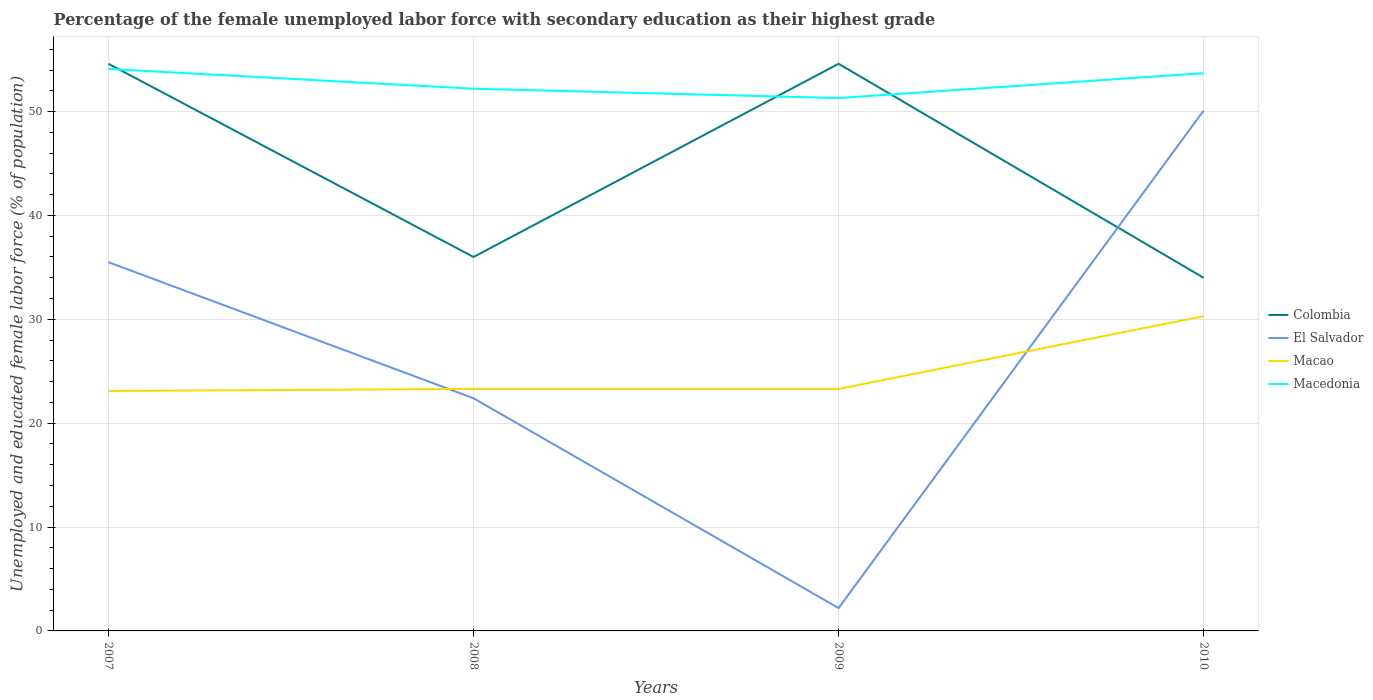Does the line corresponding to Macedonia intersect with the line corresponding to El Salvador?
Offer a terse response. No. Across all years, what is the maximum percentage of the unemployed female labor force with secondary education in Macedonia?
Ensure brevity in your answer.  51.3. In which year was the percentage of the unemployed female labor force with secondary education in Macedonia maximum?
Give a very brief answer. 2009. What is the total percentage of the unemployed female labor force with secondary education in El Salvador in the graph?
Your answer should be very brief. 13.1. What is the difference between the highest and the second highest percentage of the unemployed female labor force with secondary education in Macedonia?
Give a very brief answer. 2.8. Is the percentage of the unemployed female labor force with secondary education in Macao strictly greater than the percentage of the unemployed female labor force with secondary education in El Salvador over the years?
Provide a succinct answer. No. How many lines are there?
Your response must be concise. 4. Are the values on the major ticks of Y-axis written in scientific E-notation?
Offer a terse response. No. Does the graph contain any zero values?
Your response must be concise. No. How are the legend labels stacked?
Your answer should be very brief. Vertical. What is the title of the graph?
Make the answer very short. Percentage of the female unemployed labor force with secondary education as their highest grade. Does "High income" appear as one of the legend labels in the graph?
Provide a short and direct response. No. What is the label or title of the X-axis?
Make the answer very short. Years. What is the label or title of the Y-axis?
Give a very brief answer. Unemployed and educated female labor force (% of population). What is the Unemployed and educated female labor force (% of population) of Colombia in 2007?
Provide a short and direct response. 54.6. What is the Unemployed and educated female labor force (% of population) in El Salvador in 2007?
Ensure brevity in your answer.  35.5. What is the Unemployed and educated female labor force (% of population) in Macao in 2007?
Offer a terse response. 23.1. What is the Unemployed and educated female labor force (% of population) in Macedonia in 2007?
Ensure brevity in your answer.  54.1. What is the Unemployed and educated female labor force (% of population) in El Salvador in 2008?
Your answer should be compact. 22.4. What is the Unemployed and educated female labor force (% of population) of Macao in 2008?
Make the answer very short. 23.3. What is the Unemployed and educated female labor force (% of population) of Macedonia in 2008?
Offer a terse response. 52.2. What is the Unemployed and educated female labor force (% of population) in Colombia in 2009?
Keep it short and to the point. 54.6. What is the Unemployed and educated female labor force (% of population) of El Salvador in 2009?
Provide a short and direct response. 2.2. What is the Unemployed and educated female labor force (% of population) in Macao in 2009?
Your response must be concise. 23.3. What is the Unemployed and educated female labor force (% of population) in Macedonia in 2009?
Provide a succinct answer. 51.3. What is the Unemployed and educated female labor force (% of population) in Colombia in 2010?
Your response must be concise. 34. What is the Unemployed and educated female labor force (% of population) of El Salvador in 2010?
Ensure brevity in your answer.  50.1. What is the Unemployed and educated female labor force (% of population) in Macao in 2010?
Provide a short and direct response. 30.3. What is the Unemployed and educated female labor force (% of population) in Macedonia in 2010?
Your answer should be very brief. 53.7. Across all years, what is the maximum Unemployed and educated female labor force (% of population) of Colombia?
Your response must be concise. 54.6. Across all years, what is the maximum Unemployed and educated female labor force (% of population) of El Salvador?
Offer a very short reply. 50.1. Across all years, what is the maximum Unemployed and educated female labor force (% of population) in Macao?
Give a very brief answer. 30.3. Across all years, what is the maximum Unemployed and educated female labor force (% of population) of Macedonia?
Your answer should be compact. 54.1. Across all years, what is the minimum Unemployed and educated female labor force (% of population) of Colombia?
Give a very brief answer. 34. Across all years, what is the minimum Unemployed and educated female labor force (% of population) of El Salvador?
Keep it short and to the point. 2.2. Across all years, what is the minimum Unemployed and educated female labor force (% of population) in Macao?
Give a very brief answer. 23.1. Across all years, what is the minimum Unemployed and educated female labor force (% of population) of Macedonia?
Provide a succinct answer. 51.3. What is the total Unemployed and educated female labor force (% of population) of Colombia in the graph?
Provide a succinct answer. 179.2. What is the total Unemployed and educated female labor force (% of population) in El Salvador in the graph?
Give a very brief answer. 110.2. What is the total Unemployed and educated female labor force (% of population) in Macao in the graph?
Provide a short and direct response. 100. What is the total Unemployed and educated female labor force (% of population) in Macedonia in the graph?
Keep it short and to the point. 211.3. What is the difference between the Unemployed and educated female labor force (% of population) in Colombia in 2007 and that in 2008?
Offer a terse response. 18.6. What is the difference between the Unemployed and educated female labor force (% of population) of El Salvador in 2007 and that in 2008?
Provide a short and direct response. 13.1. What is the difference between the Unemployed and educated female labor force (% of population) in Macao in 2007 and that in 2008?
Offer a very short reply. -0.2. What is the difference between the Unemployed and educated female labor force (% of population) in El Salvador in 2007 and that in 2009?
Make the answer very short. 33.3. What is the difference between the Unemployed and educated female labor force (% of population) in Macao in 2007 and that in 2009?
Provide a succinct answer. -0.2. What is the difference between the Unemployed and educated female labor force (% of population) of Macedonia in 2007 and that in 2009?
Ensure brevity in your answer.  2.8. What is the difference between the Unemployed and educated female labor force (% of population) in Colombia in 2007 and that in 2010?
Keep it short and to the point. 20.6. What is the difference between the Unemployed and educated female labor force (% of population) of El Salvador in 2007 and that in 2010?
Provide a short and direct response. -14.6. What is the difference between the Unemployed and educated female labor force (% of population) in Macedonia in 2007 and that in 2010?
Offer a terse response. 0.4. What is the difference between the Unemployed and educated female labor force (% of population) in Colombia in 2008 and that in 2009?
Offer a terse response. -18.6. What is the difference between the Unemployed and educated female labor force (% of population) of El Salvador in 2008 and that in 2009?
Provide a succinct answer. 20.2. What is the difference between the Unemployed and educated female labor force (% of population) of Macedonia in 2008 and that in 2009?
Ensure brevity in your answer.  0.9. What is the difference between the Unemployed and educated female labor force (% of population) of El Salvador in 2008 and that in 2010?
Ensure brevity in your answer.  -27.7. What is the difference between the Unemployed and educated female labor force (% of population) in Macao in 2008 and that in 2010?
Provide a short and direct response. -7. What is the difference between the Unemployed and educated female labor force (% of population) in Macedonia in 2008 and that in 2010?
Ensure brevity in your answer.  -1.5. What is the difference between the Unemployed and educated female labor force (% of population) in Colombia in 2009 and that in 2010?
Provide a succinct answer. 20.6. What is the difference between the Unemployed and educated female labor force (% of population) in El Salvador in 2009 and that in 2010?
Offer a very short reply. -47.9. What is the difference between the Unemployed and educated female labor force (% of population) in Macao in 2009 and that in 2010?
Offer a terse response. -7. What is the difference between the Unemployed and educated female labor force (% of population) of Colombia in 2007 and the Unemployed and educated female labor force (% of population) of El Salvador in 2008?
Provide a short and direct response. 32.2. What is the difference between the Unemployed and educated female labor force (% of population) of Colombia in 2007 and the Unemployed and educated female labor force (% of population) of Macao in 2008?
Provide a short and direct response. 31.3. What is the difference between the Unemployed and educated female labor force (% of population) in Colombia in 2007 and the Unemployed and educated female labor force (% of population) in Macedonia in 2008?
Give a very brief answer. 2.4. What is the difference between the Unemployed and educated female labor force (% of population) in El Salvador in 2007 and the Unemployed and educated female labor force (% of population) in Macedonia in 2008?
Make the answer very short. -16.7. What is the difference between the Unemployed and educated female labor force (% of population) of Macao in 2007 and the Unemployed and educated female labor force (% of population) of Macedonia in 2008?
Your response must be concise. -29.1. What is the difference between the Unemployed and educated female labor force (% of population) in Colombia in 2007 and the Unemployed and educated female labor force (% of population) in El Salvador in 2009?
Give a very brief answer. 52.4. What is the difference between the Unemployed and educated female labor force (% of population) in Colombia in 2007 and the Unemployed and educated female labor force (% of population) in Macao in 2009?
Offer a terse response. 31.3. What is the difference between the Unemployed and educated female labor force (% of population) in El Salvador in 2007 and the Unemployed and educated female labor force (% of population) in Macao in 2009?
Offer a very short reply. 12.2. What is the difference between the Unemployed and educated female labor force (% of population) of El Salvador in 2007 and the Unemployed and educated female labor force (% of population) of Macedonia in 2009?
Provide a succinct answer. -15.8. What is the difference between the Unemployed and educated female labor force (% of population) in Macao in 2007 and the Unemployed and educated female labor force (% of population) in Macedonia in 2009?
Provide a succinct answer. -28.2. What is the difference between the Unemployed and educated female labor force (% of population) of Colombia in 2007 and the Unemployed and educated female labor force (% of population) of El Salvador in 2010?
Offer a terse response. 4.5. What is the difference between the Unemployed and educated female labor force (% of population) in Colombia in 2007 and the Unemployed and educated female labor force (% of population) in Macao in 2010?
Offer a terse response. 24.3. What is the difference between the Unemployed and educated female labor force (% of population) in El Salvador in 2007 and the Unemployed and educated female labor force (% of population) in Macedonia in 2010?
Your answer should be compact. -18.2. What is the difference between the Unemployed and educated female labor force (% of population) in Macao in 2007 and the Unemployed and educated female labor force (% of population) in Macedonia in 2010?
Provide a short and direct response. -30.6. What is the difference between the Unemployed and educated female labor force (% of population) in Colombia in 2008 and the Unemployed and educated female labor force (% of population) in El Salvador in 2009?
Offer a terse response. 33.8. What is the difference between the Unemployed and educated female labor force (% of population) in Colombia in 2008 and the Unemployed and educated female labor force (% of population) in Macedonia in 2009?
Your response must be concise. -15.3. What is the difference between the Unemployed and educated female labor force (% of population) of El Salvador in 2008 and the Unemployed and educated female labor force (% of population) of Macao in 2009?
Give a very brief answer. -0.9. What is the difference between the Unemployed and educated female labor force (% of population) in El Salvador in 2008 and the Unemployed and educated female labor force (% of population) in Macedonia in 2009?
Keep it short and to the point. -28.9. What is the difference between the Unemployed and educated female labor force (% of population) of Colombia in 2008 and the Unemployed and educated female labor force (% of population) of El Salvador in 2010?
Your answer should be compact. -14.1. What is the difference between the Unemployed and educated female labor force (% of population) in Colombia in 2008 and the Unemployed and educated female labor force (% of population) in Macedonia in 2010?
Your answer should be compact. -17.7. What is the difference between the Unemployed and educated female labor force (% of population) in El Salvador in 2008 and the Unemployed and educated female labor force (% of population) in Macedonia in 2010?
Offer a terse response. -31.3. What is the difference between the Unemployed and educated female labor force (% of population) of Macao in 2008 and the Unemployed and educated female labor force (% of population) of Macedonia in 2010?
Give a very brief answer. -30.4. What is the difference between the Unemployed and educated female labor force (% of population) of Colombia in 2009 and the Unemployed and educated female labor force (% of population) of El Salvador in 2010?
Make the answer very short. 4.5. What is the difference between the Unemployed and educated female labor force (% of population) in Colombia in 2009 and the Unemployed and educated female labor force (% of population) in Macao in 2010?
Offer a terse response. 24.3. What is the difference between the Unemployed and educated female labor force (% of population) in El Salvador in 2009 and the Unemployed and educated female labor force (% of population) in Macao in 2010?
Offer a very short reply. -28.1. What is the difference between the Unemployed and educated female labor force (% of population) of El Salvador in 2009 and the Unemployed and educated female labor force (% of population) of Macedonia in 2010?
Make the answer very short. -51.5. What is the difference between the Unemployed and educated female labor force (% of population) in Macao in 2009 and the Unemployed and educated female labor force (% of population) in Macedonia in 2010?
Offer a terse response. -30.4. What is the average Unemployed and educated female labor force (% of population) in Colombia per year?
Your answer should be compact. 44.8. What is the average Unemployed and educated female labor force (% of population) in El Salvador per year?
Your answer should be compact. 27.55. What is the average Unemployed and educated female labor force (% of population) of Macedonia per year?
Make the answer very short. 52.83. In the year 2007, what is the difference between the Unemployed and educated female labor force (% of population) in Colombia and Unemployed and educated female labor force (% of population) in Macao?
Offer a very short reply. 31.5. In the year 2007, what is the difference between the Unemployed and educated female labor force (% of population) of El Salvador and Unemployed and educated female labor force (% of population) of Macao?
Make the answer very short. 12.4. In the year 2007, what is the difference between the Unemployed and educated female labor force (% of population) in El Salvador and Unemployed and educated female labor force (% of population) in Macedonia?
Offer a very short reply. -18.6. In the year 2007, what is the difference between the Unemployed and educated female labor force (% of population) of Macao and Unemployed and educated female labor force (% of population) of Macedonia?
Offer a terse response. -31. In the year 2008, what is the difference between the Unemployed and educated female labor force (% of population) in Colombia and Unemployed and educated female labor force (% of population) in Macao?
Offer a terse response. 12.7. In the year 2008, what is the difference between the Unemployed and educated female labor force (% of population) of Colombia and Unemployed and educated female labor force (% of population) of Macedonia?
Provide a short and direct response. -16.2. In the year 2008, what is the difference between the Unemployed and educated female labor force (% of population) of El Salvador and Unemployed and educated female labor force (% of population) of Macedonia?
Make the answer very short. -29.8. In the year 2008, what is the difference between the Unemployed and educated female labor force (% of population) of Macao and Unemployed and educated female labor force (% of population) of Macedonia?
Offer a very short reply. -28.9. In the year 2009, what is the difference between the Unemployed and educated female labor force (% of population) of Colombia and Unemployed and educated female labor force (% of population) of El Salvador?
Provide a short and direct response. 52.4. In the year 2009, what is the difference between the Unemployed and educated female labor force (% of population) of Colombia and Unemployed and educated female labor force (% of population) of Macao?
Your response must be concise. 31.3. In the year 2009, what is the difference between the Unemployed and educated female labor force (% of population) of El Salvador and Unemployed and educated female labor force (% of population) of Macao?
Make the answer very short. -21.1. In the year 2009, what is the difference between the Unemployed and educated female labor force (% of population) in El Salvador and Unemployed and educated female labor force (% of population) in Macedonia?
Offer a terse response. -49.1. In the year 2010, what is the difference between the Unemployed and educated female labor force (% of population) in Colombia and Unemployed and educated female labor force (% of population) in El Salvador?
Provide a short and direct response. -16.1. In the year 2010, what is the difference between the Unemployed and educated female labor force (% of population) of Colombia and Unemployed and educated female labor force (% of population) of Macao?
Give a very brief answer. 3.7. In the year 2010, what is the difference between the Unemployed and educated female labor force (% of population) in Colombia and Unemployed and educated female labor force (% of population) in Macedonia?
Offer a terse response. -19.7. In the year 2010, what is the difference between the Unemployed and educated female labor force (% of population) of El Salvador and Unemployed and educated female labor force (% of population) of Macao?
Your answer should be very brief. 19.8. In the year 2010, what is the difference between the Unemployed and educated female labor force (% of population) in Macao and Unemployed and educated female labor force (% of population) in Macedonia?
Offer a terse response. -23.4. What is the ratio of the Unemployed and educated female labor force (% of population) in Colombia in 2007 to that in 2008?
Your answer should be very brief. 1.52. What is the ratio of the Unemployed and educated female labor force (% of population) in El Salvador in 2007 to that in 2008?
Make the answer very short. 1.58. What is the ratio of the Unemployed and educated female labor force (% of population) in Macao in 2007 to that in 2008?
Your answer should be very brief. 0.99. What is the ratio of the Unemployed and educated female labor force (% of population) in Macedonia in 2007 to that in 2008?
Your response must be concise. 1.04. What is the ratio of the Unemployed and educated female labor force (% of population) in El Salvador in 2007 to that in 2009?
Your answer should be compact. 16.14. What is the ratio of the Unemployed and educated female labor force (% of population) in Macedonia in 2007 to that in 2009?
Provide a succinct answer. 1.05. What is the ratio of the Unemployed and educated female labor force (% of population) of Colombia in 2007 to that in 2010?
Offer a very short reply. 1.61. What is the ratio of the Unemployed and educated female labor force (% of population) in El Salvador in 2007 to that in 2010?
Provide a succinct answer. 0.71. What is the ratio of the Unemployed and educated female labor force (% of population) of Macao in 2007 to that in 2010?
Offer a terse response. 0.76. What is the ratio of the Unemployed and educated female labor force (% of population) of Macedonia in 2007 to that in 2010?
Your answer should be compact. 1.01. What is the ratio of the Unemployed and educated female labor force (% of population) in Colombia in 2008 to that in 2009?
Your answer should be compact. 0.66. What is the ratio of the Unemployed and educated female labor force (% of population) of El Salvador in 2008 to that in 2009?
Make the answer very short. 10.18. What is the ratio of the Unemployed and educated female labor force (% of population) of Macedonia in 2008 to that in 2009?
Offer a very short reply. 1.02. What is the ratio of the Unemployed and educated female labor force (% of population) of Colombia in 2008 to that in 2010?
Offer a terse response. 1.06. What is the ratio of the Unemployed and educated female labor force (% of population) of El Salvador in 2008 to that in 2010?
Make the answer very short. 0.45. What is the ratio of the Unemployed and educated female labor force (% of population) of Macao in 2008 to that in 2010?
Make the answer very short. 0.77. What is the ratio of the Unemployed and educated female labor force (% of population) in Macedonia in 2008 to that in 2010?
Provide a succinct answer. 0.97. What is the ratio of the Unemployed and educated female labor force (% of population) of Colombia in 2009 to that in 2010?
Keep it short and to the point. 1.61. What is the ratio of the Unemployed and educated female labor force (% of population) in El Salvador in 2009 to that in 2010?
Your answer should be very brief. 0.04. What is the ratio of the Unemployed and educated female labor force (% of population) of Macao in 2009 to that in 2010?
Ensure brevity in your answer.  0.77. What is the ratio of the Unemployed and educated female labor force (% of population) in Macedonia in 2009 to that in 2010?
Your answer should be very brief. 0.96. What is the difference between the highest and the second highest Unemployed and educated female labor force (% of population) in Colombia?
Your answer should be very brief. 0. What is the difference between the highest and the second highest Unemployed and educated female labor force (% of population) in El Salvador?
Offer a terse response. 14.6. What is the difference between the highest and the second highest Unemployed and educated female labor force (% of population) of Macao?
Your response must be concise. 7. What is the difference between the highest and the lowest Unemployed and educated female labor force (% of population) of Colombia?
Offer a very short reply. 20.6. What is the difference between the highest and the lowest Unemployed and educated female labor force (% of population) in El Salvador?
Offer a terse response. 47.9. What is the difference between the highest and the lowest Unemployed and educated female labor force (% of population) in Macao?
Offer a very short reply. 7.2. 